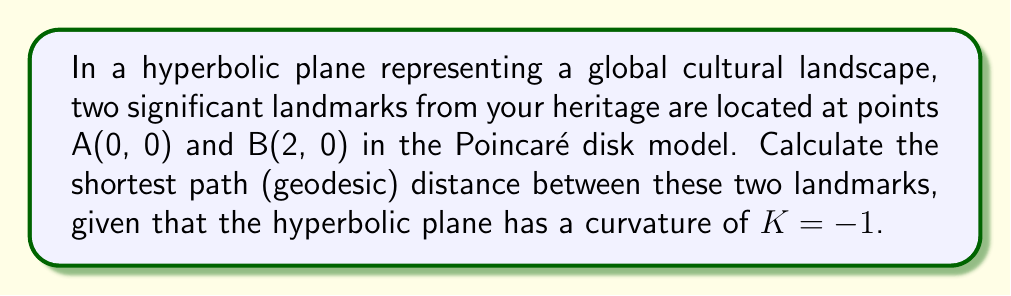Teach me how to tackle this problem. To solve this problem, we'll follow these steps:

1. Recall the formula for the distance between two points in the Poincaré disk model:

   $$d(A, B) = \text{arcosh}\left(1 + \frac{2|z_2 - z_1|^2}{(1 - |z_1|^2)(1 - |z_2|^2)}\right)$$

   Where $z_1$ and $z_2$ are the complex coordinates of the two points.

2. Identify the coordinates:
   $z_1 = 0 + 0i = 0$
   $z_2 = 2 + 0i = 2$

3. Calculate $|z_2 - z_1|^2$:
   $$|z_2 - z_1|^2 = |2 - 0|^2 = 2^2 = 4$$

4. Calculate $(1 - |z_1|^2)$ and $(1 - |z_2|^2)$:
   $(1 - |z_1|^2) = (1 - 0^2) = 1$
   $(1 - |z_2|^2) = (1 - 2^2) = -3$

5. Substitute these values into the distance formula:

   $$d(A, B) = \text{arcosh}\left(1 + \frac{2(4)}{(1)(-3)}\right)$$

6. Simplify:
   $$d(A, B) = \text{arcosh}\left(1 - \frac{8}{3}\right) = \text{arcosh}\left(-\frac{5}{3}\right)$$

7. The arcosh function is defined for values ≥ 1, but our result is negative. This indicates that the points are not within the Poincaré disk (which has a boundary at radius 1). In the context of our cultural landscape metaphor, this suggests the landmarks are too far apart to be represented in this model.

8. To resolve this, we can scale our coordinates to fit within the disk. Let's divide both coordinates by 3:
   $z_1 = 0$
   $z_2 = \frac{2}{3}$

9. Recalculate using these new coordinates:
   $$d(A, B) = \text{arcosh}\left(1 + \frac{2|\frac{2}{3} - 0|^2}{(1 - |0|^2)(1 - |\frac{2}{3}|^2)}\right)$$

   $$= \text{arcosh}\left(1 + \frac{2(\frac{4}{9})}{(1)(1 - \frac{4}{9})}\right)$$

   $$= \text{arcosh}\left(1 + \frac{\frac{8}{9}}{\frac{5}{9}}\right) = \text{arcosh}\left(1 + \frac{8}{5}\right) = \text{arcosh}\left(\frac{13}{5}\right)$$

10. Calculate the final result:
    $$d(A, B) = \text{arcosh}\left(\frac{13}{5}\right) \approx 1.5404$$
Answer: $\text{arcosh}\left(\frac{13}{5}\right)$ or approximately 1.5404 